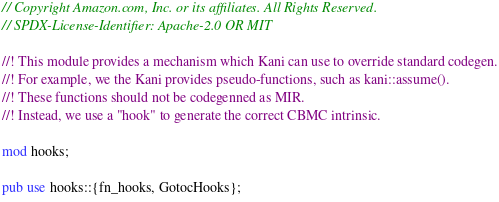Convert code to text. <code><loc_0><loc_0><loc_500><loc_500><_Rust_>// Copyright Amazon.com, Inc. or its affiliates. All Rights Reserved.
// SPDX-License-Identifier: Apache-2.0 OR MIT

//! This module provides a mechanism which Kani can use to override standard codegen.
//! For example, we the Kani provides pseudo-functions, such as kani::assume().
//! These functions should not be codegenned as MIR.
//! Instead, we use a "hook" to generate the correct CBMC intrinsic.

mod hooks;

pub use hooks::{fn_hooks, GotocHooks};
</code> 